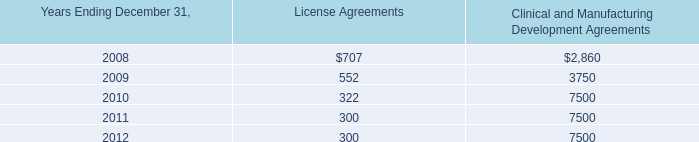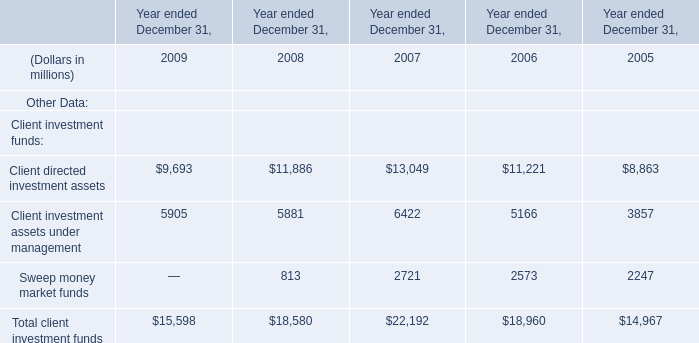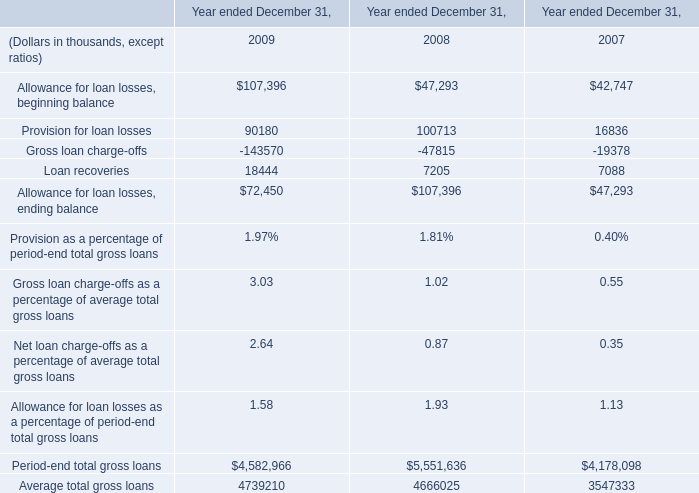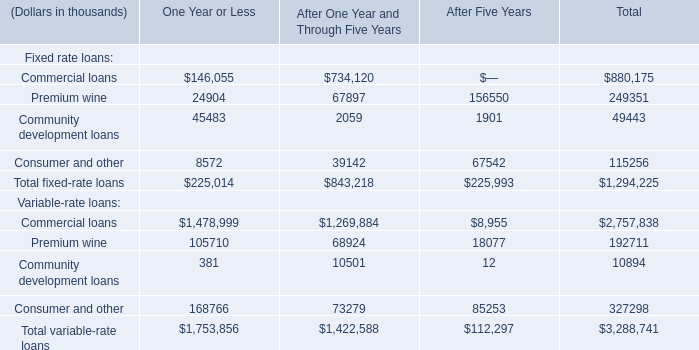What's the sum of Sweep money market funds of Year ended December 31, 2005, and Provision for loan losses of Year ended December 31, 2009 ? 
Computations: (2247.0 + 90180.0)
Answer: 92427.0. 